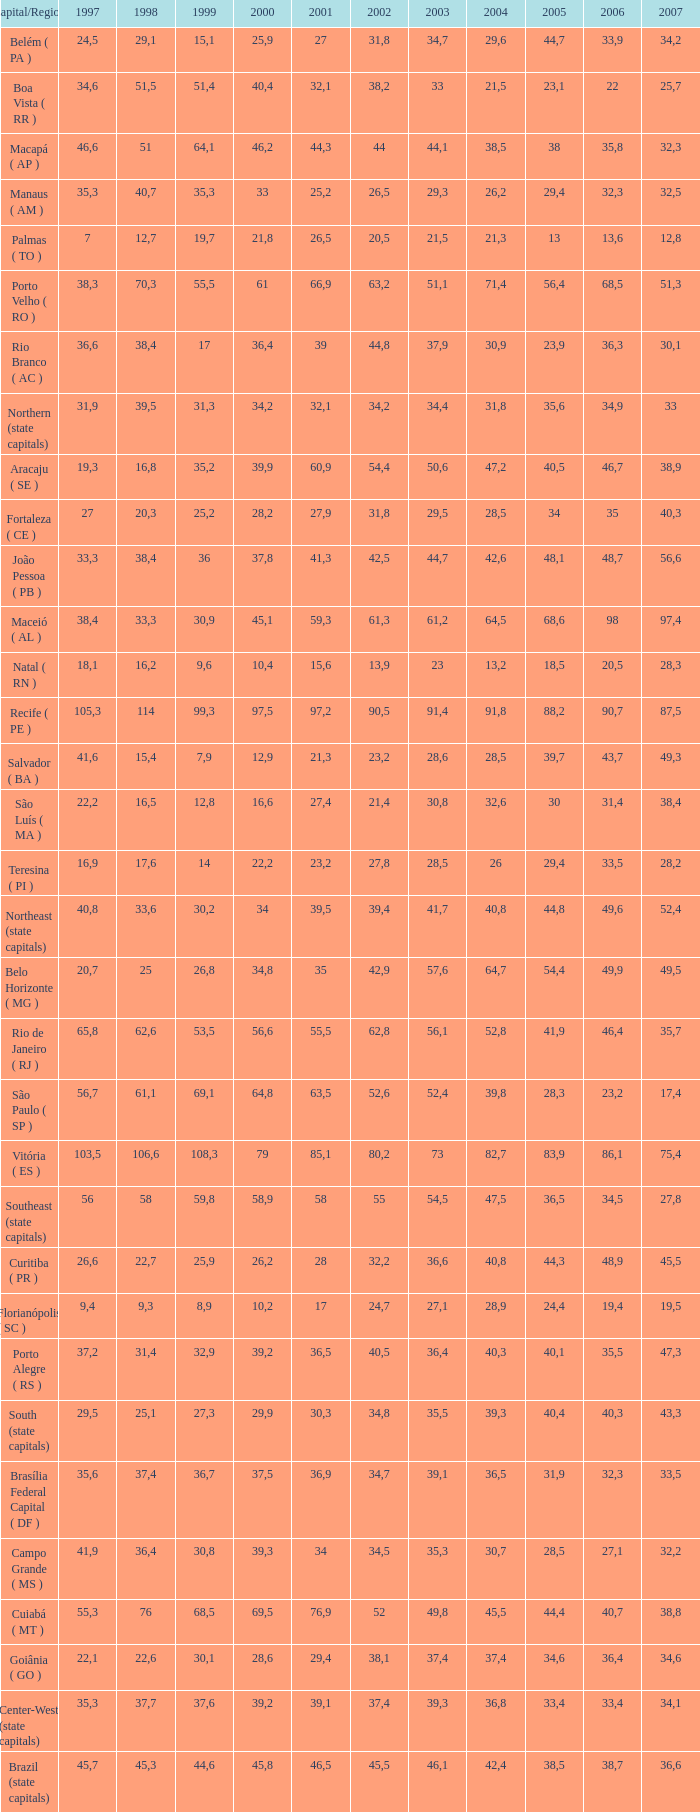Could you parse the entire table as a dict? {'header': ['Capital/Region', '1997', '1998', '1999', '2000', '2001', '2002', '2003', '2004', '2005', '2006', '2007'], 'rows': [['Belém ( PA )', '24,5', '29,1', '15,1', '25,9', '27', '31,8', '34,7', '29,6', '44,7', '33,9', '34,2'], ['Boa Vista ( RR )', '34,6', '51,5', '51,4', '40,4', '32,1', '38,2', '33', '21,5', '23,1', '22', '25,7'], ['Macapá ( AP )', '46,6', '51', '64,1', '46,2', '44,3', '44', '44,1', '38,5', '38', '35,8', '32,3'], ['Manaus ( AM )', '35,3', '40,7', '35,3', '33', '25,2', '26,5', '29,3', '26,2', '29,4', '32,3', '32,5'], ['Palmas ( TO )', '7', '12,7', '19,7', '21,8', '26,5', '20,5', '21,5', '21,3', '13', '13,6', '12,8'], ['Porto Velho ( RO )', '38,3', '70,3', '55,5', '61', '66,9', '63,2', '51,1', '71,4', '56,4', '68,5', '51,3'], ['Rio Branco ( AC )', '36,6', '38,4', '17', '36,4', '39', '44,8', '37,9', '30,9', '23,9', '36,3', '30,1'], ['Northern (state capitals)', '31,9', '39,5', '31,3', '34,2', '32,1', '34,2', '34,4', '31,8', '35,6', '34,9', '33'], ['Aracaju ( SE )', '19,3', '16,8', '35,2', '39,9', '60,9', '54,4', '50,6', '47,2', '40,5', '46,7', '38,9'], ['Fortaleza ( CE )', '27', '20,3', '25,2', '28,2', '27,9', '31,8', '29,5', '28,5', '34', '35', '40,3'], ['João Pessoa ( PB )', '33,3', '38,4', '36', '37,8', '41,3', '42,5', '44,7', '42,6', '48,1', '48,7', '56,6'], ['Maceió ( AL )', '38,4', '33,3', '30,9', '45,1', '59,3', '61,3', '61,2', '64,5', '68,6', '98', '97,4'], ['Natal ( RN )', '18,1', '16,2', '9,6', '10,4', '15,6', '13,9', '23', '13,2', '18,5', '20,5', '28,3'], ['Recife ( PE )', '105,3', '114', '99,3', '97,5', '97,2', '90,5', '91,4', '91,8', '88,2', '90,7', '87,5'], ['Salvador ( BA )', '41,6', '15,4', '7,9', '12,9', '21,3', '23,2', '28,6', '28,5', '39,7', '43,7', '49,3'], ['São Luís ( MA )', '22,2', '16,5', '12,8', '16,6', '27,4', '21,4', '30,8', '32,6', '30', '31,4', '38,4'], ['Teresina ( PI )', '16,9', '17,6', '14', '22,2', '23,2', '27,8', '28,5', '26', '29,4', '33,5', '28,2'], ['Northeast (state capitals)', '40,8', '33,6', '30,2', '34', '39,5', '39,4', '41,7', '40,8', '44,8', '49,6', '52,4'], ['Belo Horizonte ( MG )', '20,7', '25', '26,8', '34,8', '35', '42,9', '57,6', '64,7', '54,4', '49,9', '49,5'], ['Rio de Janeiro ( RJ )', '65,8', '62,6', '53,5', '56,6', '55,5', '62,8', '56,1', '52,8', '41,9', '46,4', '35,7'], ['São Paulo ( SP )', '56,7', '61,1', '69,1', '64,8', '63,5', '52,6', '52,4', '39,8', '28,3', '23,2', '17,4'], ['Vitória ( ES )', '103,5', '106,6', '108,3', '79', '85,1', '80,2', '73', '82,7', '83,9', '86,1', '75,4'], ['Southeast (state capitals)', '56', '58', '59,8', '58,9', '58', '55', '54,5', '47,5', '36,5', '34,5', '27,8'], ['Curitiba ( PR )', '26,6', '22,7', '25,9', '26,2', '28', '32,2', '36,6', '40,8', '44,3', '48,9', '45,5'], ['Florianópolis ( SC )', '9,4', '9,3', '8,9', '10,2', '17', '24,7', '27,1', '28,9', '24,4', '19,4', '19,5'], ['Porto Alegre ( RS )', '37,2', '31,4', '32,9', '39,2', '36,5', '40,5', '36,4', '40,3', '40,1', '35,5', '47,3'], ['South (state capitals)', '29,5', '25,1', '27,3', '29,9', '30,3', '34,8', '35,5', '39,3', '40,4', '40,3', '43,3'], ['Brasília Federal Capital ( DF )', '35,6', '37,4', '36,7', '37,5', '36,9', '34,7', '39,1', '36,5', '31,9', '32,3', '33,5'], ['Campo Grande ( MS )', '41,9', '36,4', '30,8', '39,3', '34', '34,5', '35,3', '30,7', '28,5', '27,1', '32,2'], ['Cuiabá ( MT )', '55,3', '76', '68,5', '69,5', '76,9', '52', '49,8', '45,5', '44,4', '40,7', '38,8'], ['Goiânia ( GO )', '22,1', '22,6', '30,1', '28,6', '29,4', '38,1', '37,4', '37,4', '34,6', '36,4', '34,6'], ['Center-West (state capitals)', '35,3', '37,7', '37,6', '39,2', '39,1', '37,4', '39,3', '36,8', '33,4', '33,4', '34,1'], ['Brazil (state capitals)', '45,7', '45,3', '44,6', '45,8', '46,5', '45,5', '46,1', '42,4', '38,5', '38,7', '36,6']]} How many 2007's feature a 2003 lesser than 36,4, 27,9 as a 2001, and a 1999 smaller than 25,2? None. 